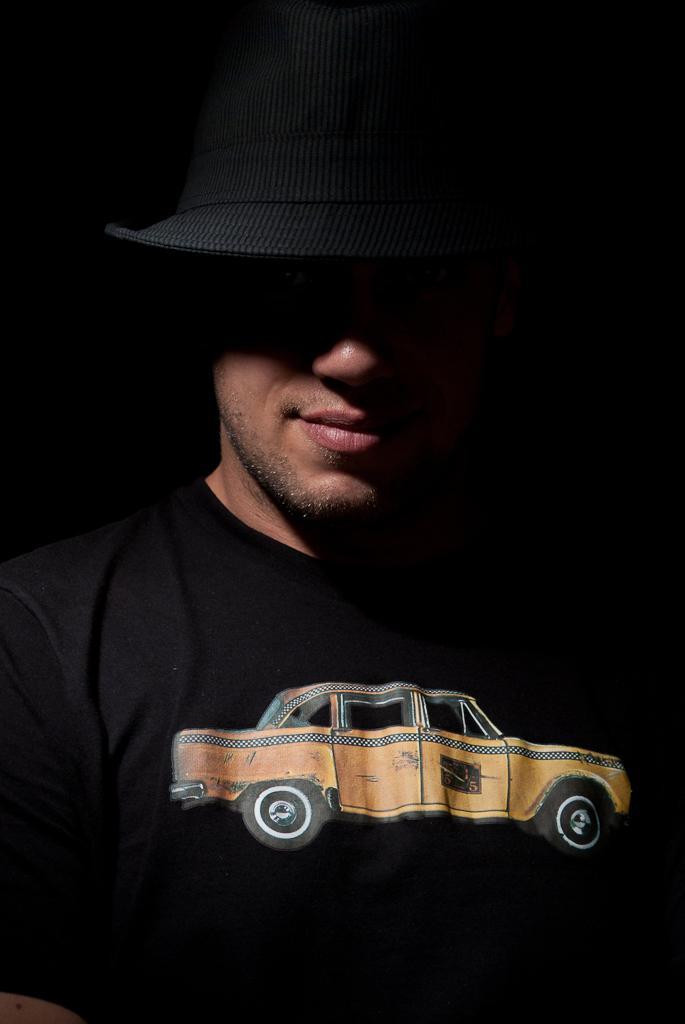How would you summarize this image in a sentence or two? In this image there is a person wearing black shirt and black cap. There is a car painting on the shirt. 